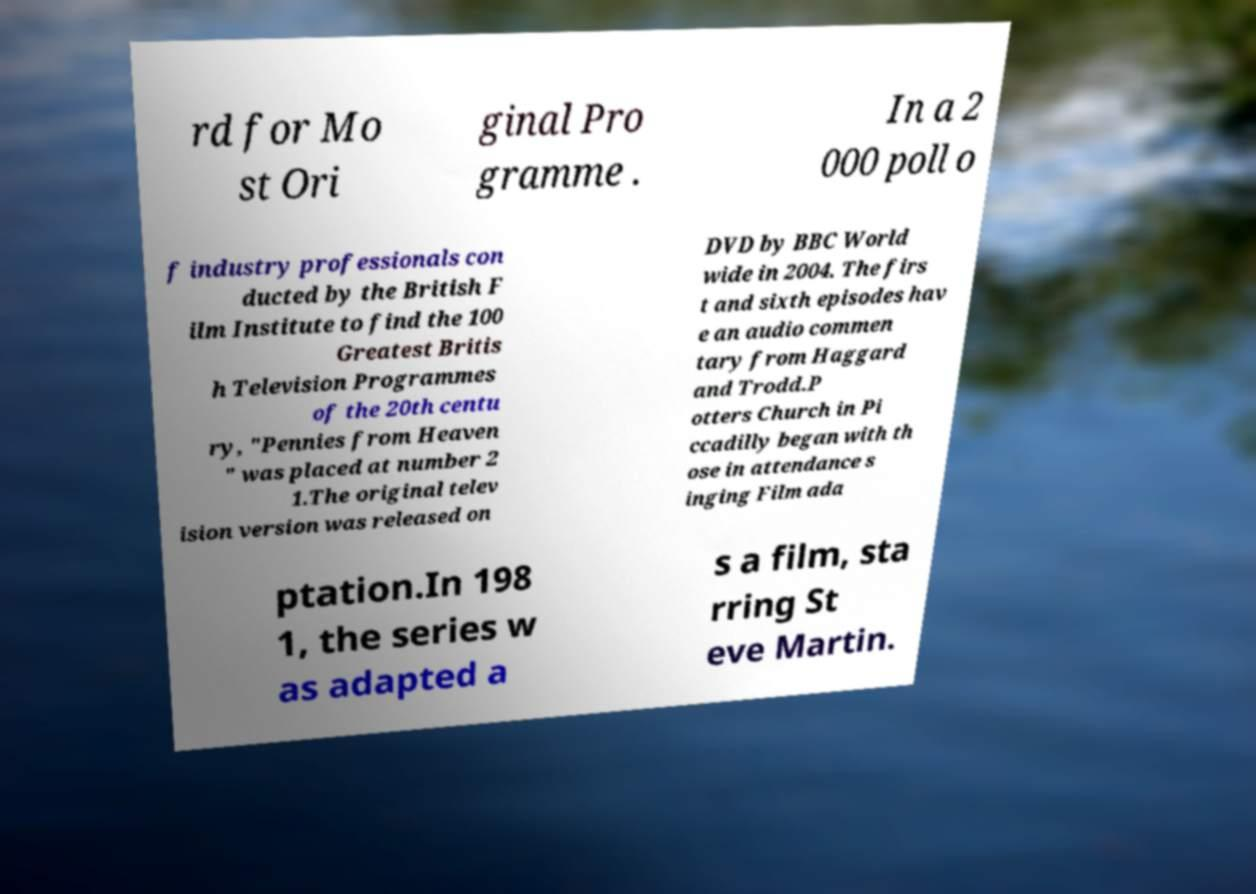Can you accurately transcribe the text from the provided image for me? rd for Mo st Ori ginal Pro gramme . In a 2 000 poll o f industry professionals con ducted by the British F ilm Institute to find the 100 Greatest Britis h Television Programmes of the 20th centu ry, "Pennies from Heaven " was placed at number 2 1.The original telev ision version was released on DVD by BBC World wide in 2004. The firs t and sixth episodes hav e an audio commen tary from Haggard and Trodd.P otters Church in Pi ccadilly began with th ose in attendance s inging Film ada ptation.In 198 1, the series w as adapted a s a film, sta rring St eve Martin. 